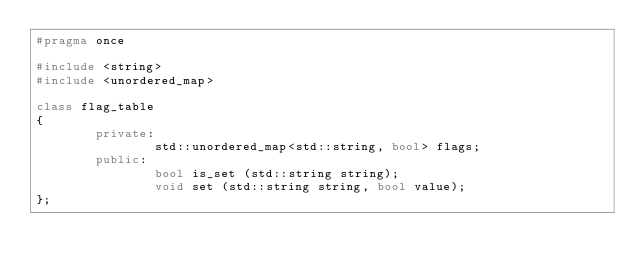Convert code to text. <code><loc_0><loc_0><loc_500><loc_500><_C++_>#pragma once

#include <string>
#include <unordered_map>

class flag_table
{
        private:
                std::unordered_map<std::string, bool> flags;
        public:
                bool is_set (std::string string);
                void set (std::string string, bool value);
};
</code> 